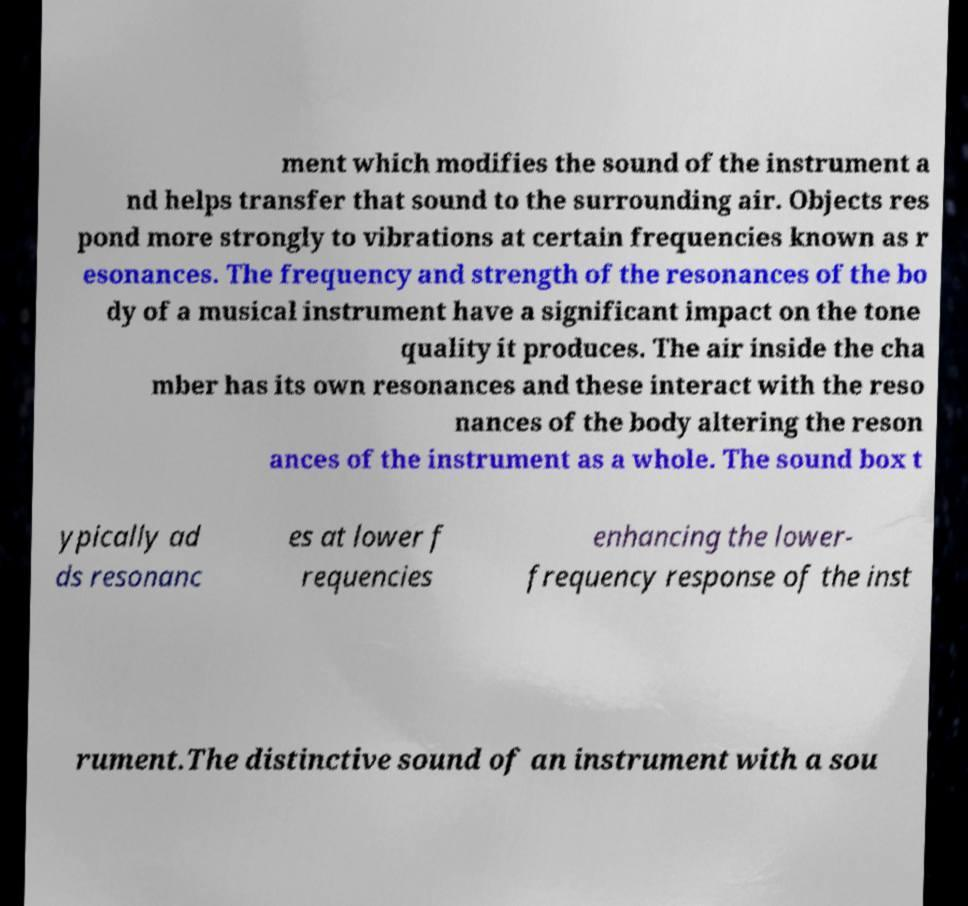I need the written content from this picture converted into text. Can you do that? ment which modifies the sound of the instrument a nd helps transfer that sound to the surrounding air. Objects res pond more strongly to vibrations at certain frequencies known as r esonances. The frequency and strength of the resonances of the bo dy of a musical instrument have a significant impact on the tone quality it produces. The air inside the cha mber has its own resonances and these interact with the reso nances of the body altering the reson ances of the instrument as a whole. The sound box t ypically ad ds resonanc es at lower f requencies enhancing the lower- frequency response of the inst rument.The distinctive sound of an instrument with a sou 